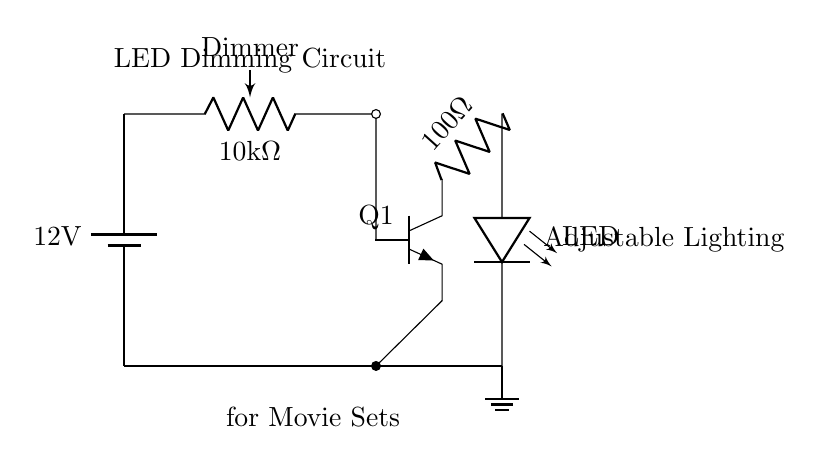What is the power supply voltage? The power supply is indicated in the circuit as a battery labeled with "12V." This is the voltage supplied to the circuit components.
Answer: 12V What component acts as the dimmer in this circuit? The dimmer is represented as a potentiometer labeled "Dimmer" with a resistance of "10kΩ." This component adjusts the brightness of the LED by changing resistance.
Answer: Dimmer What type of transistor is used in this circuit? The circuit diagram specifies an NPN transistor, labeled as "Q1." It is commonly used in switching applications, such as modulating the LED brightness.
Answer: NPN What is the purpose of the 100-ohm resistor? The 100-ohm resistor is connected to the collector of the transistor and is used to limit the current flowing through the LED, protecting it from excess current.
Answer: Current limiting How does the adjustment of the potentiometer affect the circuit? Adjusting the potentiometer changes its resistance, which affects the base current into the transistor. This modulates the on/off state of the transistor and subsequently adjusts the brightness of the LED.
Answer: Brightness change What is the output component in this circuit? The output component is the LED, it is represented in the circuit diagram and is where the adjustable lighting occurs.
Answer: LED 